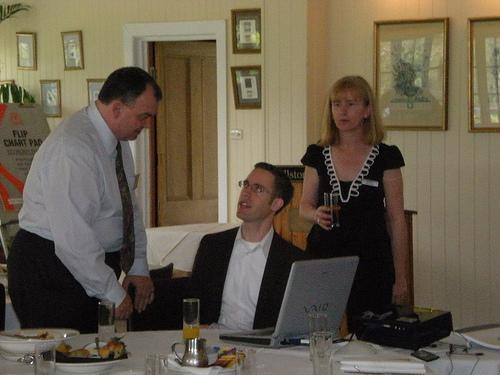Where is this venue likely to be? Please explain your reasoning. conference room. There is a long table with a laptop and a projector on it. 